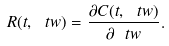<formula> <loc_0><loc_0><loc_500><loc_500>R ( t , \ t w ) = \frac { \partial C ( t , \ t w ) } { \partial \ t w } .</formula> 